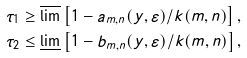Convert formula to latex. <formula><loc_0><loc_0><loc_500><loc_500>\tau _ { 1 } & \geq \varlimsup \left [ 1 - a _ { m , n } ( y , \varepsilon ) / k ( m , n ) \right ] , \\ \tau _ { 2 } & \leq \varliminf \left [ 1 - b _ { m , n } ( y , \varepsilon ) / k ( m , n ) \right ] ,</formula> 